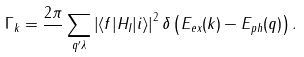<formula> <loc_0><loc_0><loc_500><loc_500>\Gamma _ { k } = \frac { 2 \pi } { } \sum _ { { q } ^ { \prime } \lambda } \left | \langle f | H _ { I } | i \rangle \right | ^ { 2 } \delta \left ( E _ { e x } ( k ) - E _ { p h } ( q ) \right ) .</formula> 